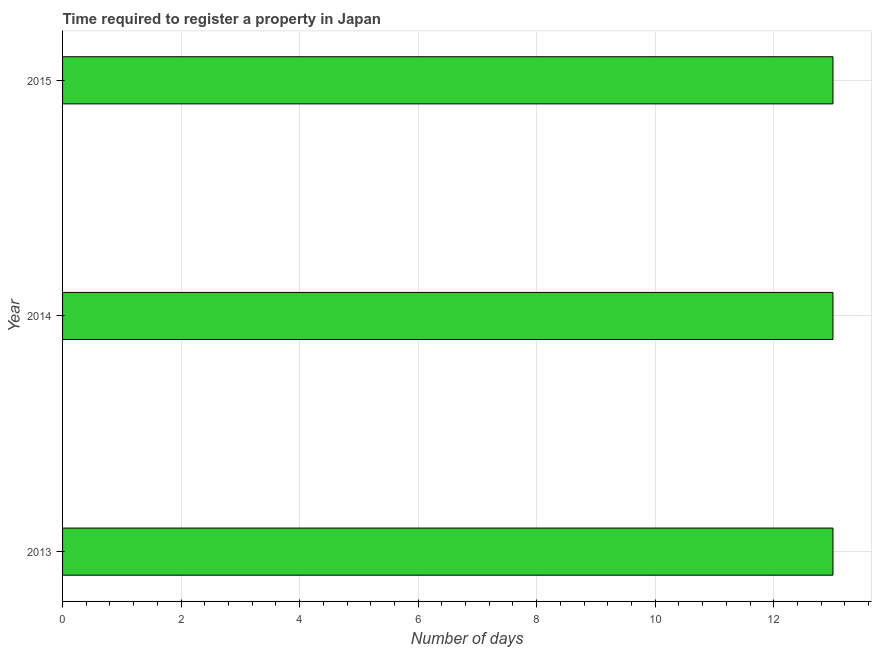Does the graph contain grids?
Your answer should be very brief. Yes. What is the title of the graph?
Ensure brevity in your answer.  Time required to register a property in Japan. What is the label or title of the X-axis?
Provide a succinct answer. Number of days. What is the label or title of the Y-axis?
Make the answer very short. Year. Across all years, what is the maximum number of days required to register property?
Offer a terse response. 13. In which year was the number of days required to register property maximum?
Offer a terse response. 2013. In which year was the number of days required to register property minimum?
Provide a short and direct response. 2013. What is the average number of days required to register property per year?
Keep it short and to the point. 13. In how many years, is the number of days required to register property greater than 5.6 days?
Offer a terse response. 3. What is the ratio of the number of days required to register property in 2013 to that in 2014?
Provide a succinct answer. 1. Is the difference between the number of days required to register property in 2013 and 2014 greater than the difference between any two years?
Keep it short and to the point. Yes. What is the difference between the highest and the second highest number of days required to register property?
Give a very brief answer. 0. What is the difference between the highest and the lowest number of days required to register property?
Your answer should be compact. 0. Are all the bars in the graph horizontal?
Offer a terse response. Yes. How many years are there in the graph?
Offer a terse response. 3. What is the difference between two consecutive major ticks on the X-axis?
Make the answer very short. 2. Are the values on the major ticks of X-axis written in scientific E-notation?
Provide a short and direct response. No. What is the difference between the Number of days in 2013 and 2014?
Your response must be concise. 0. What is the difference between the Number of days in 2013 and 2015?
Give a very brief answer. 0. What is the ratio of the Number of days in 2013 to that in 2015?
Your answer should be compact. 1. What is the ratio of the Number of days in 2014 to that in 2015?
Offer a very short reply. 1. 